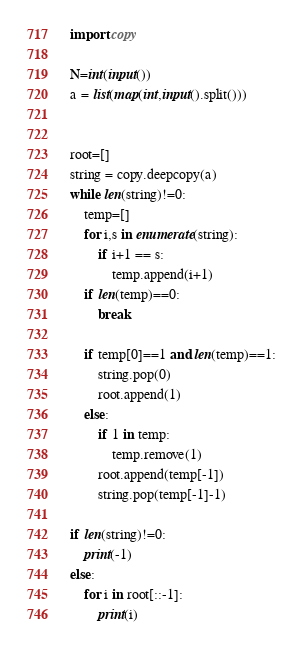Convert code to text. <code><loc_0><loc_0><loc_500><loc_500><_Python_>import copy

N=int(input())
a = list(map(int,input().split()))


root=[]
string = copy.deepcopy(a)
while len(string)!=0:
    temp=[]
    for i,s in enumerate(string):
        if i+1 == s:
            temp.append(i+1)
    if len(temp)==0:
        break
    
    if temp[0]==1 and len(temp)==1:
        string.pop(0)
        root.append(1)
    else:
        if 1 in temp:
            temp.remove(1)
        root.append(temp[-1])
        string.pop(temp[-1]-1)
        
if len(string)!=0:
    print(-1)
else:
    for i in root[::-1]:
        print(i)</code> 